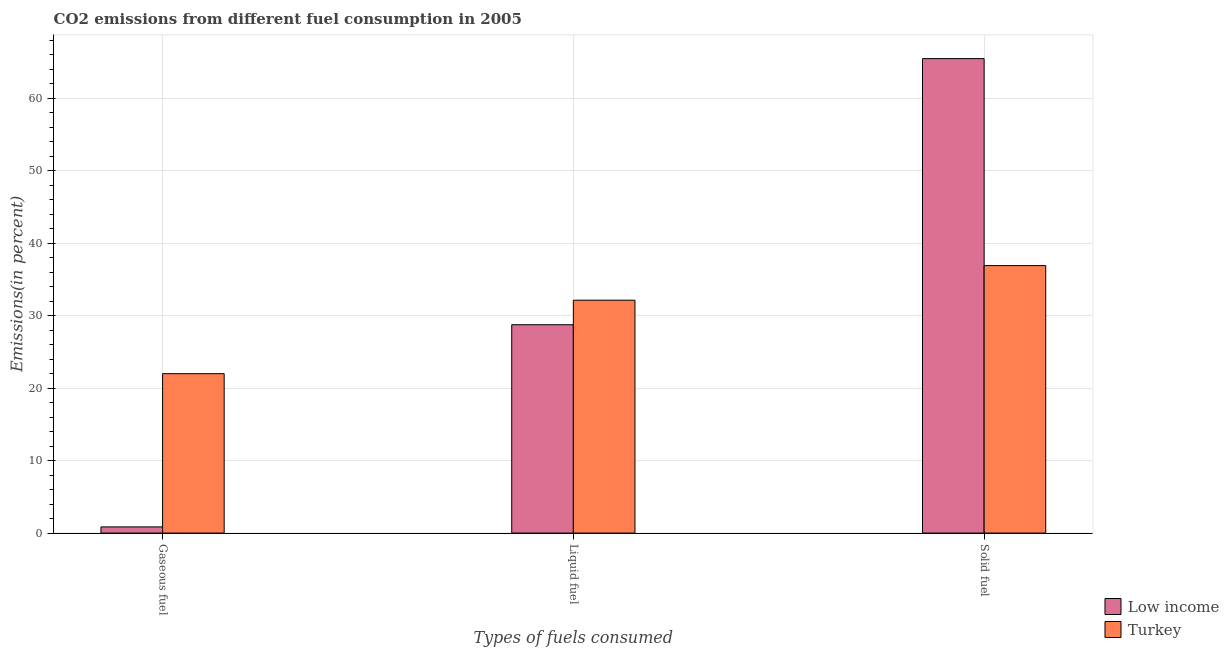How many different coloured bars are there?
Your answer should be compact. 2. How many groups of bars are there?
Your answer should be very brief. 3. Are the number of bars on each tick of the X-axis equal?
Your answer should be very brief. Yes. How many bars are there on the 1st tick from the right?
Ensure brevity in your answer.  2. What is the label of the 2nd group of bars from the left?
Keep it short and to the point. Liquid fuel. What is the percentage of liquid fuel emission in Low income?
Your answer should be very brief. 28.74. Across all countries, what is the maximum percentage of liquid fuel emission?
Offer a very short reply. 32.12. Across all countries, what is the minimum percentage of solid fuel emission?
Offer a terse response. 36.9. What is the total percentage of gaseous fuel emission in the graph?
Provide a succinct answer. 22.84. What is the difference between the percentage of gaseous fuel emission in Turkey and that in Low income?
Your answer should be compact. 21.14. What is the difference between the percentage of liquid fuel emission in Low income and the percentage of gaseous fuel emission in Turkey?
Keep it short and to the point. 6.75. What is the average percentage of solid fuel emission per country?
Ensure brevity in your answer.  51.17. What is the difference between the percentage of liquid fuel emission and percentage of solid fuel emission in Low income?
Provide a succinct answer. -36.71. What is the ratio of the percentage of gaseous fuel emission in Low income to that in Turkey?
Your answer should be compact. 0.04. Is the percentage of solid fuel emission in Low income less than that in Turkey?
Provide a succinct answer. No. What is the difference between the highest and the second highest percentage of solid fuel emission?
Provide a succinct answer. 28.55. What is the difference between the highest and the lowest percentage of liquid fuel emission?
Your response must be concise. 3.38. Is the sum of the percentage of liquid fuel emission in Turkey and Low income greater than the maximum percentage of solid fuel emission across all countries?
Ensure brevity in your answer.  No. What does the 2nd bar from the left in Liquid fuel represents?
Ensure brevity in your answer.  Turkey. What does the 1st bar from the right in Solid fuel represents?
Ensure brevity in your answer.  Turkey. Is it the case that in every country, the sum of the percentage of gaseous fuel emission and percentage of liquid fuel emission is greater than the percentage of solid fuel emission?
Make the answer very short. No. What is the difference between two consecutive major ticks on the Y-axis?
Your answer should be very brief. 10. Does the graph contain grids?
Give a very brief answer. Yes. How are the legend labels stacked?
Offer a very short reply. Vertical. What is the title of the graph?
Provide a short and direct response. CO2 emissions from different fuel consumption in 2005. What is the label or title of the X-axis?
Provide a succinct answer. Types of fuels consumed. What is the label or title of the Y-axis?
Your response must be concise. Emissions(in percent). What is the Emissions(in percent) of Low income in Gaseous fuel?
Your answer should be compact. 0.85. What is the Emissions(in percent) of Turkey in Gaseous fuel?
Offer a very short reply. 21.99. What is the Emissions(in percent) of Low income in Liquid fuel?
Provide a succinct answer. 28.74. What is the Emissions(in percent) of Turkey in Liquid fuel?
Offer a very short reply. 32.12. What is the Emissions(in percent) in Low income in Solid fuel?
Offer a terse response. 65.45. What is the Emissions(in percent) in Turkey in Solid fuel?
Your answer should be compact. 36.9. Across all Types of fuels consumed, what is the maximum Emissions(in percent) of Low income?
Offer a very short reply. 65.45. Across all Types of fuels consumed, what is the maximum Emissions(in percent) in Turkey?
Provide a short and direct response. 36.9. Across all Types of fuels consumed, what is the minimum Emissions(in percent) of Low income?
Offer a very short reply. 0.85. Across all Types of fuels consumed, what is the minimum Emissions(in percent) in Turkey?
Provide a succinct answer. 21.99. What is the total Emissions(in percent) of Low income in the graph?
Keep it short and to the point. 95.04. What is the total Emissions(in percent) in Turkey in the graph?
Your response must be concise. 91.01. What is the difference between the Emissions(in percent) in Low income in Gaseous fuel and that in Liquid fuel?
Offer a terse response. -27.89. What is the difference between the Emissions(in percent) in Turkey in Gaseous fuel and that in Liquid fuel?
Give a very brief answer. -10.13. What is the difference between the Emissions(in percent) in Low income in Gaseous fuel and that in Solid fuel?
Keep it short and to the point. -64.6. What is the difference between the Emissions(in percent) in Turkey in Gaseous fuel and that in Solid fuel?
Your answer should be compact. -14.91. What is the difference between the Emissions(in percent) in Low income in Liquid fuel and that in Solid fuel?
Give a very brief answer. -36.71. What is the difference between the Emissions(in percent) of Turkey in Liquid fuel and that in Solid fuel?
Keep it short and to the point. -4.77. What is the difference between the Emissions(in percent) of Low income in Gaseous fuel and the Emissions(in percent) of Turkey in Liquid fuel?
Provide a succinct answer. -31.27. What is the difference between the Emissions(in percent) of Low income in Gaseous fuel and the Emissions(in percent) of Turkey in Solid fuel?
Ensure brevity in your answer.  -36.04. What is the difference between the Emissions(in percent) in Low income in Liquid fuel and the Emissions(in percent) in Turkey in Solid fuel?
Provide a short and direct response. -8.16. What is the average Emissions(in percent) in Low income per Types of fuels consumed?
Give a very brief answer. 31.68. What is the average Emissions(in percent) in Turkey per Types of fuels consumed?
Your answer should be very brief. 30.34. What is the difference between the Emissions(in percent) of Low income and Emissions(in percent) of Turkey in Gaseous fuel?
Keep it short and to the point. -21.14. What is the difference between the Emissions(in percent) of Low income and Emissions(in percent) of Turkey in Liquid fuel?
Provide a short and direct response. -3.38. What is the difference between the Emissions(in percent) in Low income and Emissions(in percent) in Turkey in Solid fuel?
Give a very brief answer. 28.55. What is the ratio of the Emissions(in percent) in Low income in Gaseous fuel to that in Liquid fuel?
Provide a succinct answer. 0.03. What is the ratio of the Emissions(in percent) in Turkey in Gaseous fuel to that in Liquid fuel?
Ensure brevity in your answer.  0.68. What is the ratio of the Emissions(in percent) of Low income in Gaseous fuel to that in Solid fuel?
Keep it short and to the point. 0.01. What is the ratio of the Emissions(in percent) of Turkey in Gaseous fuel to that in Solid fuel?
Your answer should be compact. 0.6. What is the ratio of the Emissions(in percent) of Low income in Liquid fuel to that in Solid fuel?
Your answer should be very brief. 0.44. What is the ratio of the Emissions(in percent) in Turkey in Liquid fuel to that in Solid fuel?
Provide a succinct answer. 0.87. What is the difference between the highest and the second highest Emissions(in percent) of Low income?
Keep it short and to the point. 36.71. What is the difference between the highest and the second highest Emissions(in percent) in Turkey?
Provide a succinct answer. 4.77. What is the difference between the highest and the lowest Emissions(in percent) in Low income?
Your answer should be very brief. 64.6. What is the difference between the highest and the lowest Emissions(in percent) in Turkey?
Give a very brief answer. 14.91. 